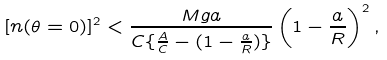<formula> <loc_0><loc_0><loc_500><loc_500>[ n ( \theta = 0 ) ] ^ { 2 } < \frac { M g a } { C \{ \frac { A } { C } - ( 1 - \frac { a } { R } ) \} } \left ( 1 - \frac { a } { R } \right ) ^ { 2 } ,</formula> 